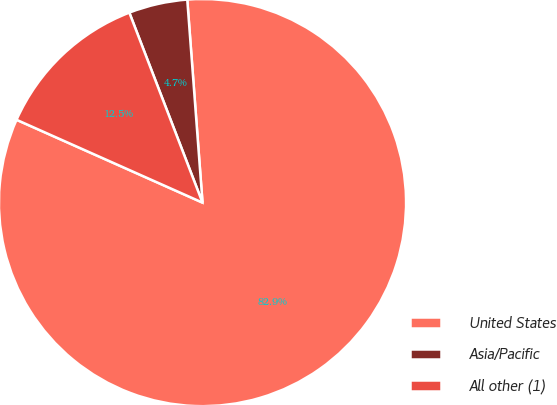<chart> <loc_0><loc_0><loc_500><loc_500><pie_chart><fcel>United States<fcel>Asia/Pacific<fcel>All other (1)<nl><fcel>82.87%<fcel>4.66%<fcel>12.48%<nl></chart> 